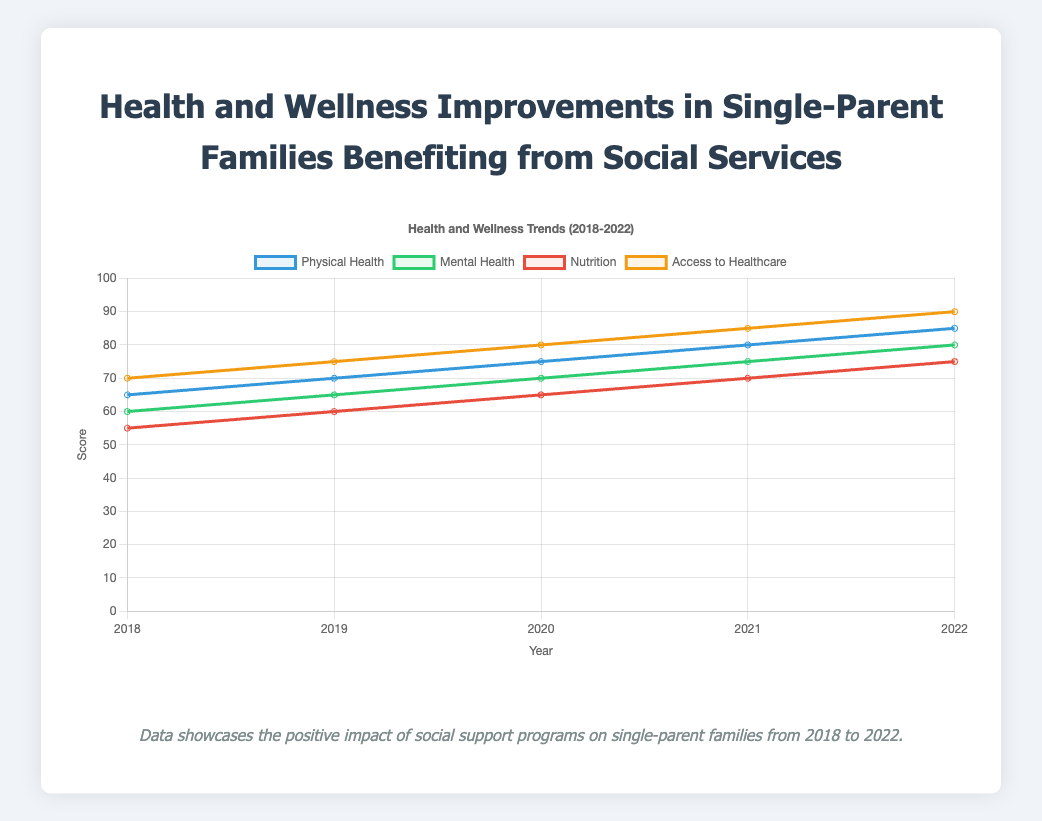What's the average value for Access to Healthcare scores from 2018 to 2022? First, sum the values for Access to Healthcare scores for each year: 70 (2018) + 75 (2019) + 80 (2020) + 85 (2021) + 90 (2022) = 400. Then, divide by the number of years (5): 400 / 5 = 80
Answer: 80 Which category showed the highest improvement from 2018 to 2022? Calculate the difference between the values for each category in 2022 and 2018. Physical Health: 85 - 65 = 20, Mental Health: 80 - 60 = 20, Nutrition: 75 - 55 = 20, Access to Healthcare: 90 - 70 = 20. All categories showed equal improvement.
Answer: All categories showed equal improvement Which year did Nutrition scores surpass 60? By examining the figures, we see the Nutrition score exceeds 60 for the first time in 2020 when it reached 65.
Answer: 2020 Between Physical Health and Mental Health, which had a higher value in 2020, and by how much? In 2020, the value for Physical Health is 75, and for Mental Health is 70. The difference is 75 - 70 = 5
Answer: Physical Health by 5 Which category had the lowest score in 2018, and what was it? The lowest score in 2018 was for Nutrition with a score of 55.
Answer: Nutrition, 55 Between 2019 and 2020, which category saw the largest increase in value? Compare the increases for each category from 2019 to 2020: Physical Health: 75 - 70 = 5, Mental Health: 70 - 65 = 5, Nutrition: 65 - 60 = 5, Access to Healthcare: 80 - 75 = 5. The increase for all categories is the same: 5.
Answer: All categories increased by 5 What is the median value of Mental Health scores from 2018 to 2022? List the values of Mental Health scores in ascending order: 60, 65, 70, 75, 80. The median value is the middle number, which is 70.
Answer: 70 Using visual attributes, which category is represented by the line with the highest final point in 2022? The line representing Access to Healthcare ends at the highest point in 2022 with a score of 90.
Answer: Access to Healthcare 